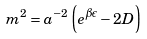Convert formula to latex. <formula><loc_0><loc_0><loc_500><loc_500>m ^ { 2 } = a ^ { - 2 } \left ( e ^ { \beta \epsilon } - 2 D \right )</formula> 